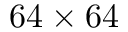<formula> <loc_0><loc_0><loc_500><loc_500>6 4 \times 6 4</formula> 